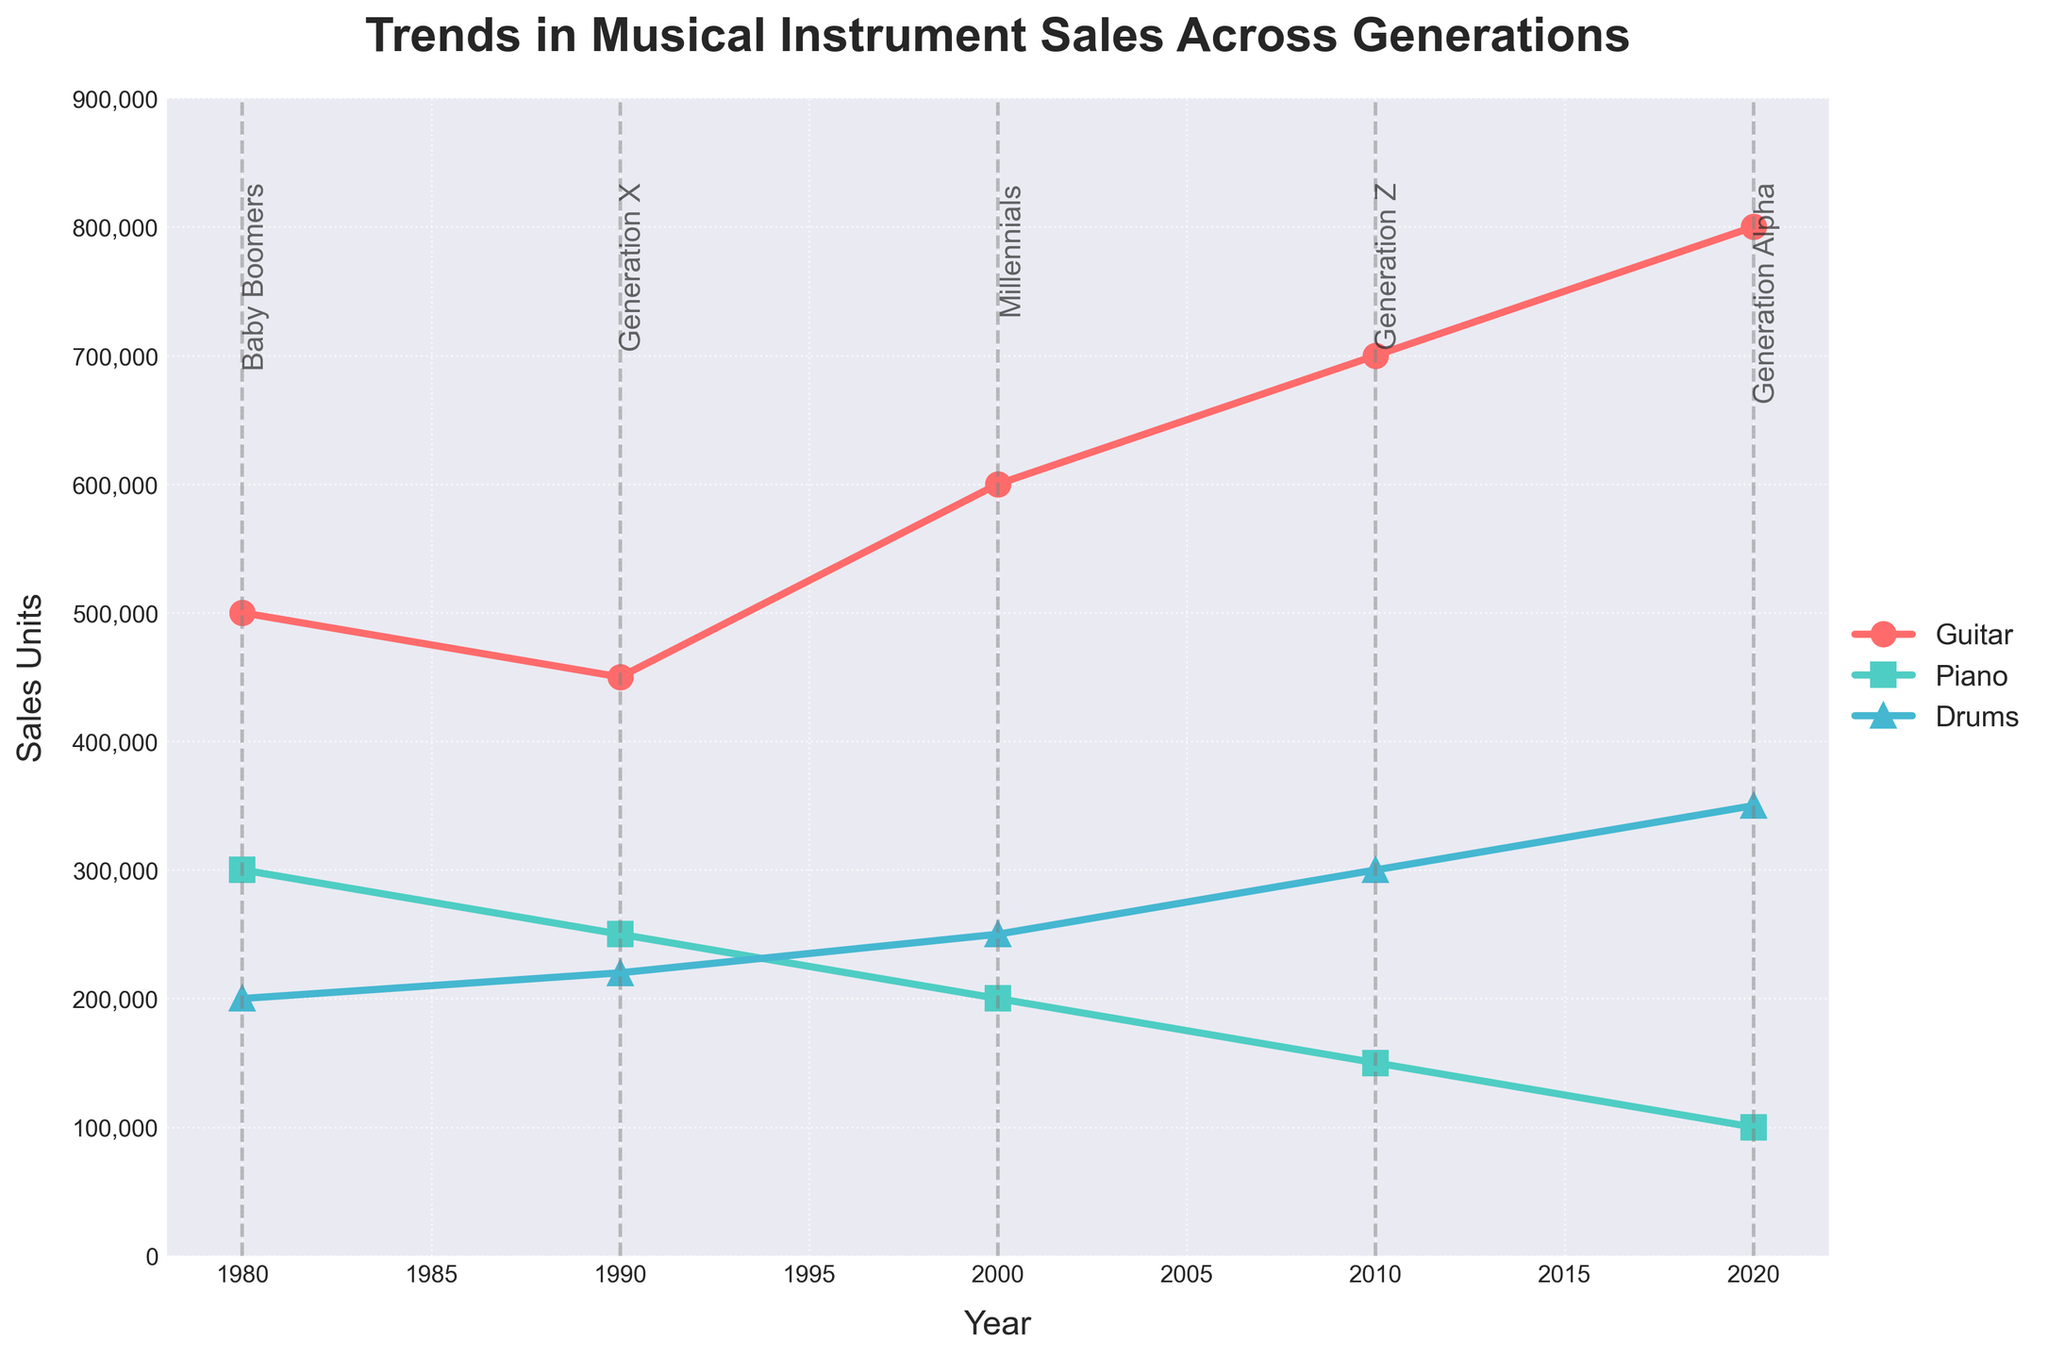What is the title of the plot? The title is typically found at the top of the plot, and it summarizes what the plot is about. The title in this plot is "Trends in Musical Instrument Sales Across Generations".
Answer: Trends in Musical Instrument Sales Across Generations Which instrument has the highest sales units in 2020? To determine this, look at the data points for each instrument in 2020. The instrument with the highest corresponding sales units is the one with the highest y-value. In 2020, the Guitar has the highest sales units.
Answer: Guitar How did the sales of pianos change from 1980 to 2020? To see this trend, look at the sales units of pianos at the beginning and end of the given years. The sales units for pianos decreased from 300,000 in 1980 to 100,000 in 2020.
Answer: Decreased Which generation showed the highest preference for drums? Check the data points for drums across different generations and identify the generation with the highest sales units for drums. Generation Alpha has the highest sales units for drums with 350,000 units.
Answer: Generation Alpha Comparing the sales units of guitars in 1980 and 2010, which year had higher sales? Look at the sales units for guitars in both 1980 and 2010. The sales units in 2010 (700,000) are higher than in 1980 (500,000).
Answer: 2010 What is the total sales of all instruments in 2010? Add the sales units of all three instruments (guitar, piano, drums) for the year 2010. The total is 700,000 + 150,000 + 300,000 = 1,150,000 units.
Answer: 1,150,000 Which instrument saw the greatest increase in sales units from 2000 to 2020? Calculate the difference in sales units for each instrument between 2000 and 2020, then compare these differences. The differences are Guitar: 800,000 - 600,000 = 200,000, Piano: 100,000 - 200,000 = -100,000, Drums: 350,000 - 250,000 = 100,000. The instrument with the greatest increase is Guitar.
Answer: Guitar What is the average sales units of pianos across all years given? Add the sales units for pianos from all the years and divide by the number of years. The total is 300,000 + 250,000 + 200,000 + 150,000 + 100,000 = 1,000,000. There are 5 data points, so the average is 1,000,000 / 5 = 200,000.
Answer: 200,000 What was the trend in guitar sales from 1980 to 2020? Look at the sales units of guitars across the years and observe if it generally increased, decreased, or stayed the same. The trend shows a steady increase from 500,000 units in 1980 to 800,000 units in 2020.
Answer: Increasing 